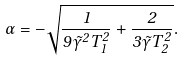<formula> <loc_0><loc_0><loc_500><loc_500>\alpha = - \sqrt { \frac { 1 } { 9 \tilde { \gamma } ^ { 2 } T _ { 1 } ^ { 2 } } + \frac { 2 } { 3 \tilde { \gamma } T _ { 2 } ^ { 2 } } } .</formula> 